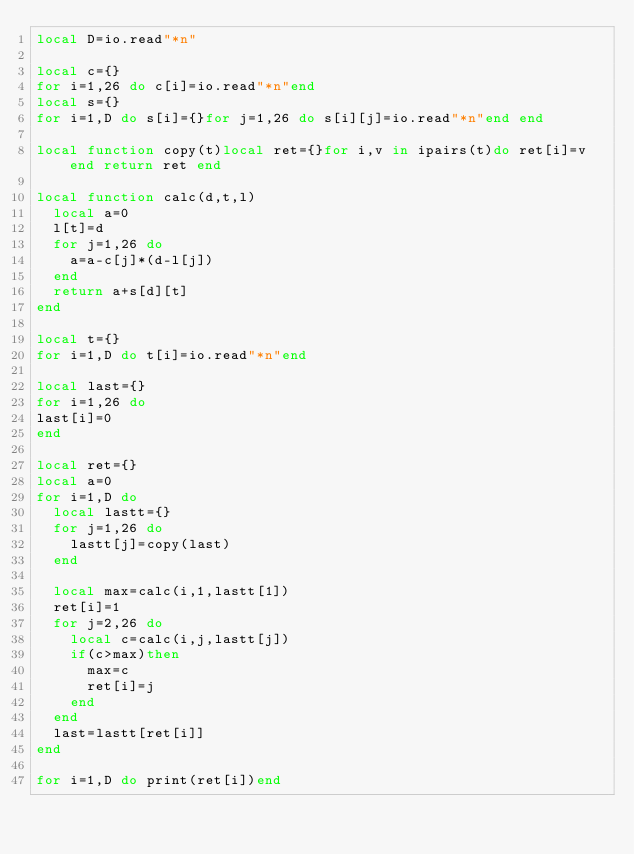Convert code to text. <code><loc_0><loc_0><loc_500><loc_500><_Lua_>local D=io.read"*n"

local c={}
for i=1,26 do c[i]=io.read"*n"end
local s={}
for i=1,D do s[i]={}for j=1,26 do s[i][j]=io.read"*n"end end

local function copy(t)local ret={}for i,v in ipairs(t)do ret[i]=v end return ret end

local function calc(d,t,l)
	local a=0
	l[t]=d
	for j=1,26 do
		a=a-c[j]*(d-l[j])
	end
	return a+s[d][t]
end

local t={}
for i=1,D do t[i]=io.read"*n"end

local last={}
for i=1,26 do
last[i]=0
end

local ret={}
local a=0
for i=1,D do
	local lastt={}
	for j=1,26 do
		lastt[j]=copy(last)
	end
	
	local max=calc(i,1,lastt[1])
	ret[i]=1
	for j=2,26 do
		local c=calc(i,j,lastt[j])
		if(c>max)then
			max=c
			ret[i]=j
		end
	end
	last=lastt[ret[i]]
end

for i=1,D do print(ret[i])end</code> 